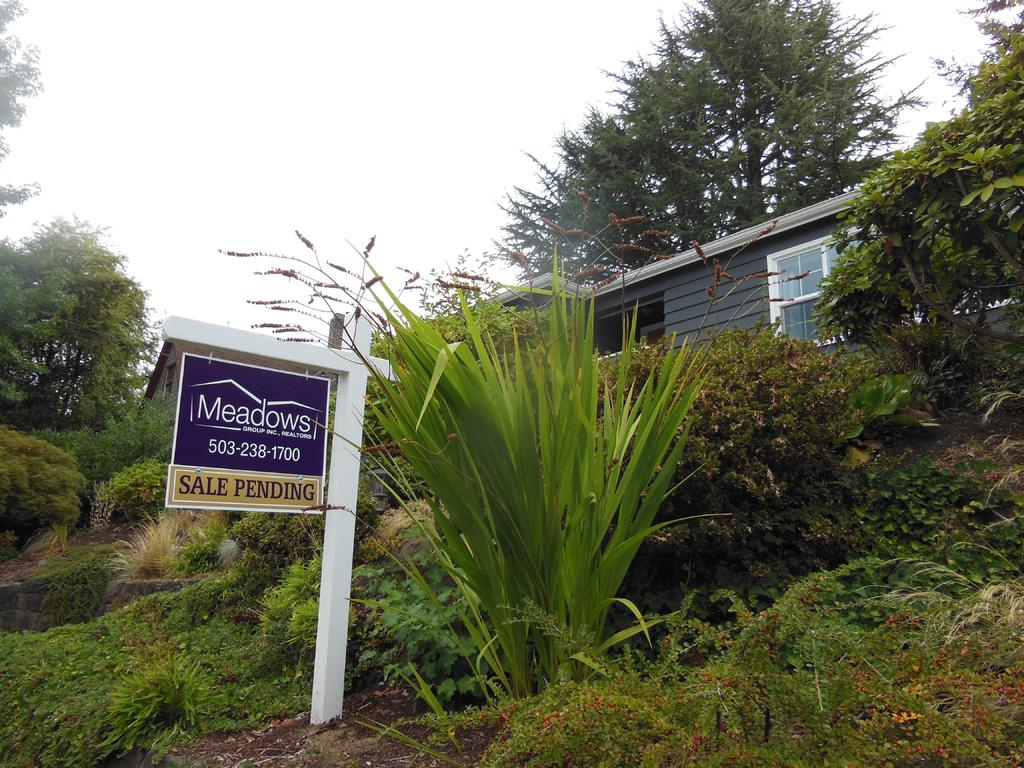What type of vegetation can be seen in the image? There are plants and trees in the image. What type of structure is visible in the image? There is a building in the image. What is the name of the event or location mentioned on the banner? The banner in the image has the text "Meadows." What type of texture can be seen on the wrench in the image? There is no wrench present in the image. 